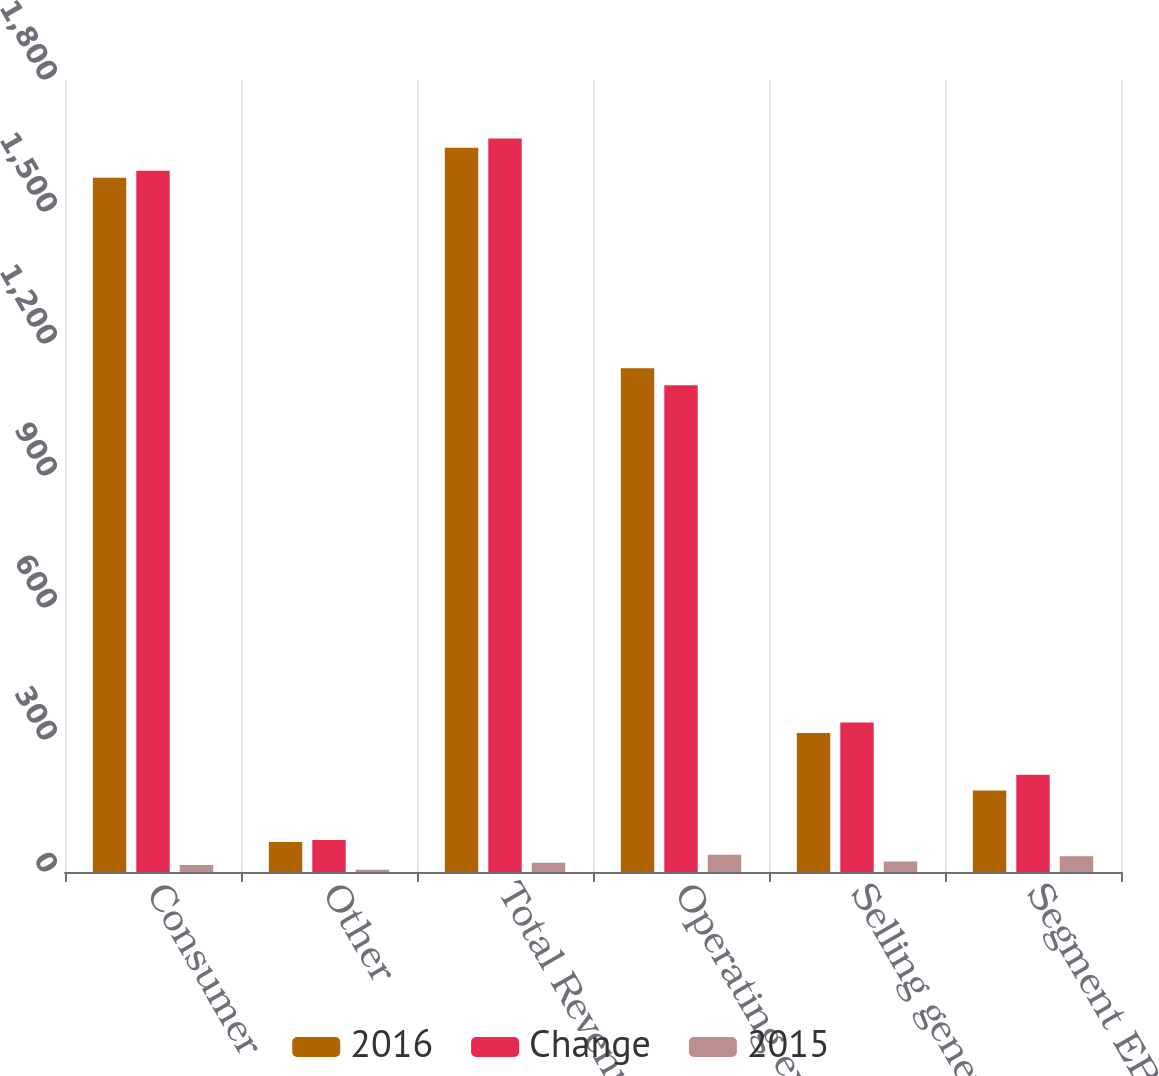Convert chart. <chart><loc_0><loc_0><loc_500><loc_500><stacked_bar_chart><ecel><fcel>Consumer<fcel>Other<fcel>Total Revenues<fcel>Operating expenses<fcel>Selling general and<fcel>Segment EBITDA<nl><fcel>2016<fcel>1578<fcel>68<fcel>1646<fcel>1145<fcel>316<fcel>185<nl><fcel>Change<fcel>1594<fcel>73<fcel>1667<fcel>1106<fcel>340<fcel>221<nl><fcel>2015<fcel>16<fcel>5<fcel>21<fcel>39<fcel>24<fcel>36<nl></chart> 